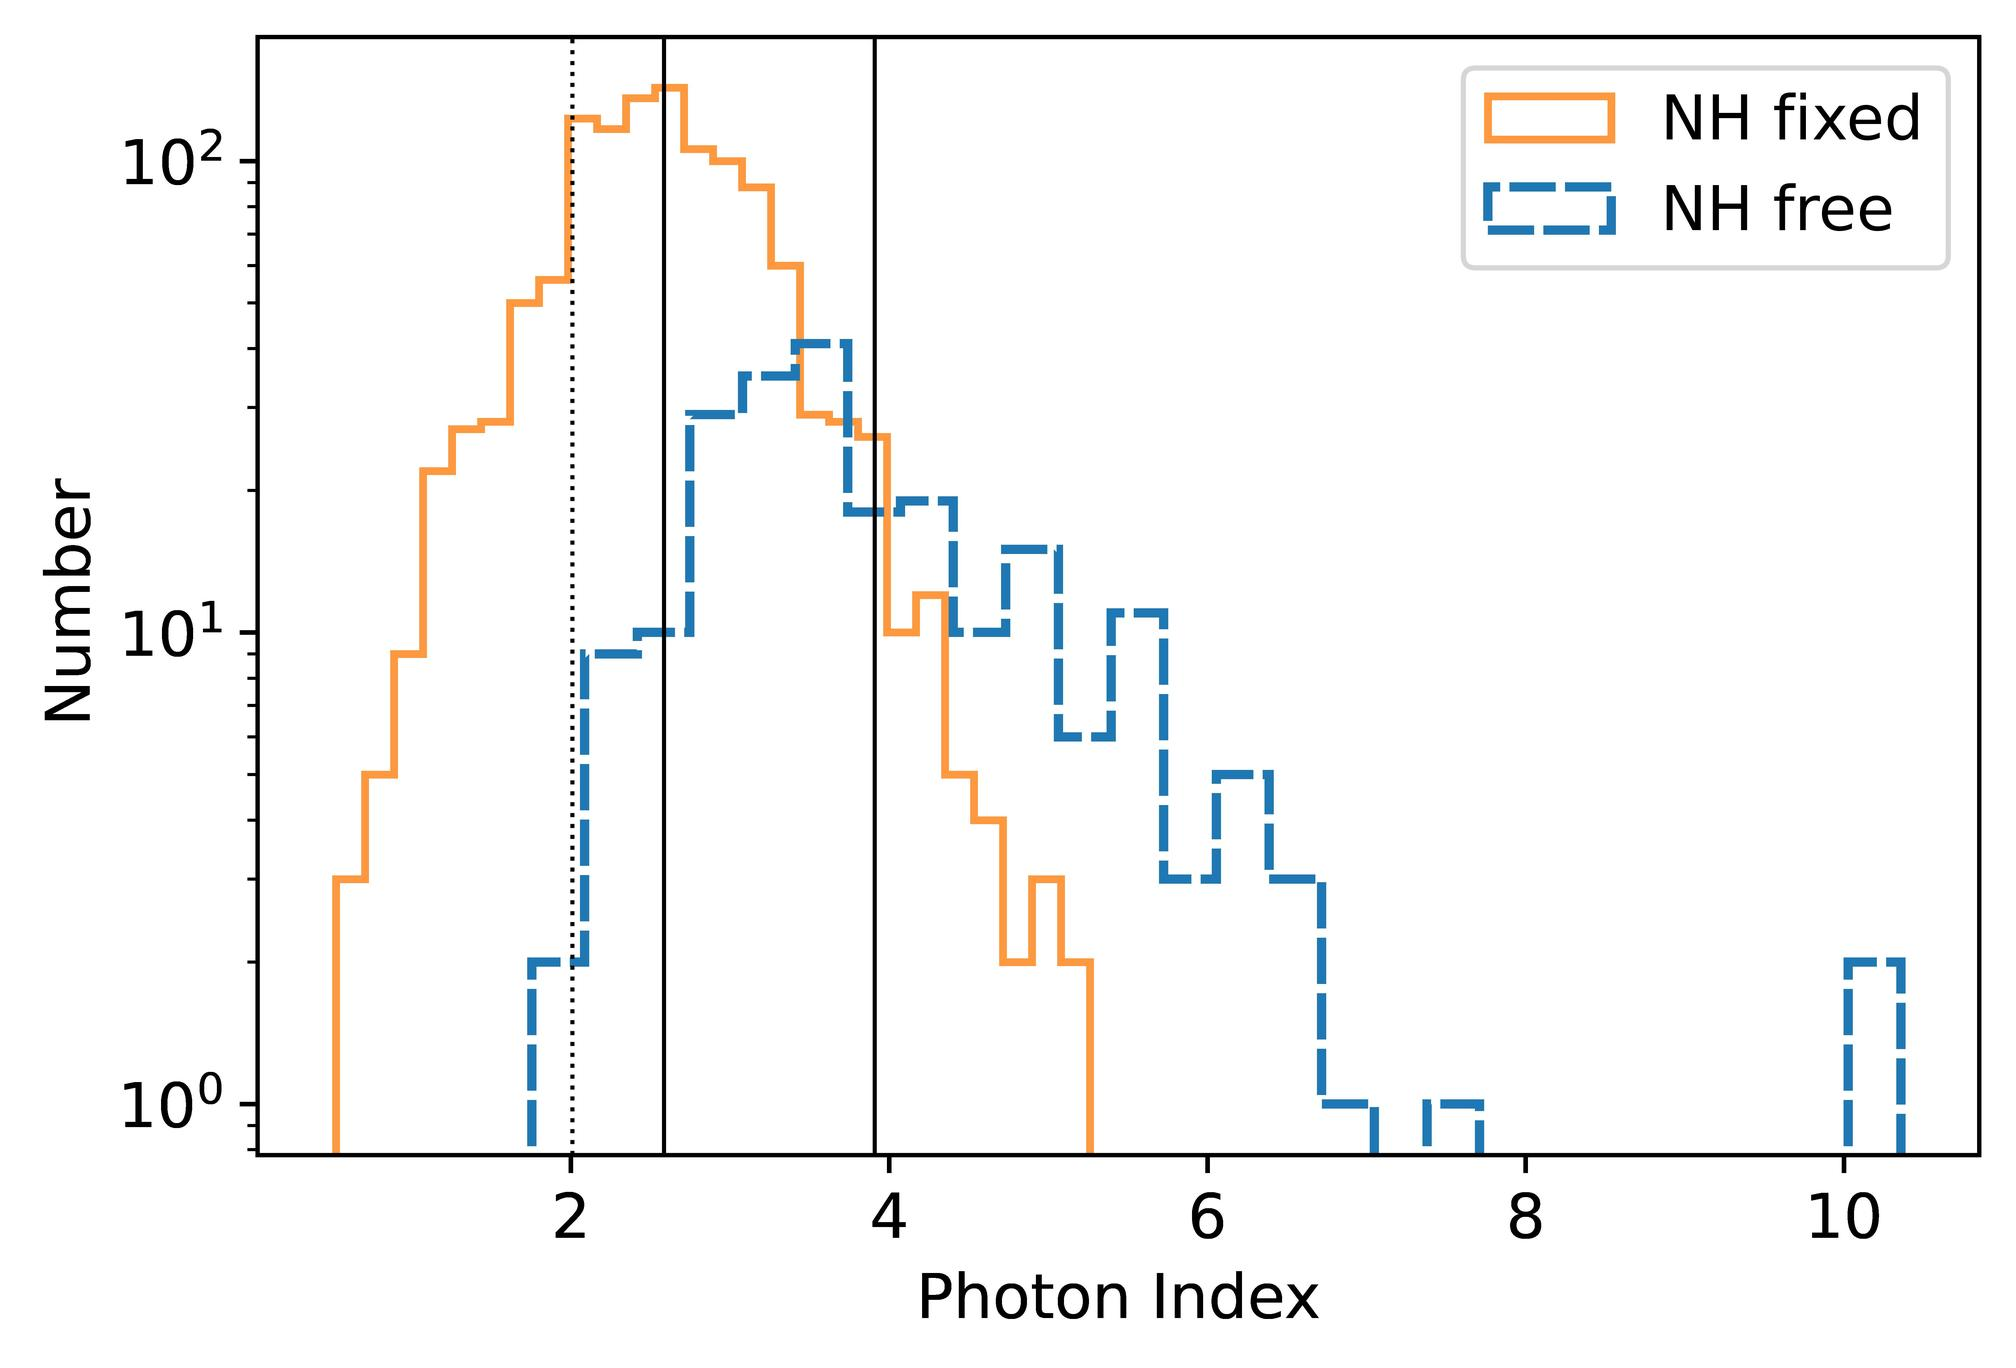At which photon index value does the distribution for NH fixed peak? Around 2.0 Around 3.0 Between 4.0 and 5.0 No clear peak is observable The peak of the histogram representing NH fixed (solid line) appears to occur around the photon index value of 3.0, as it is the tallest bar in the NH fixed distribution. Therefore, the correct answer is B. 